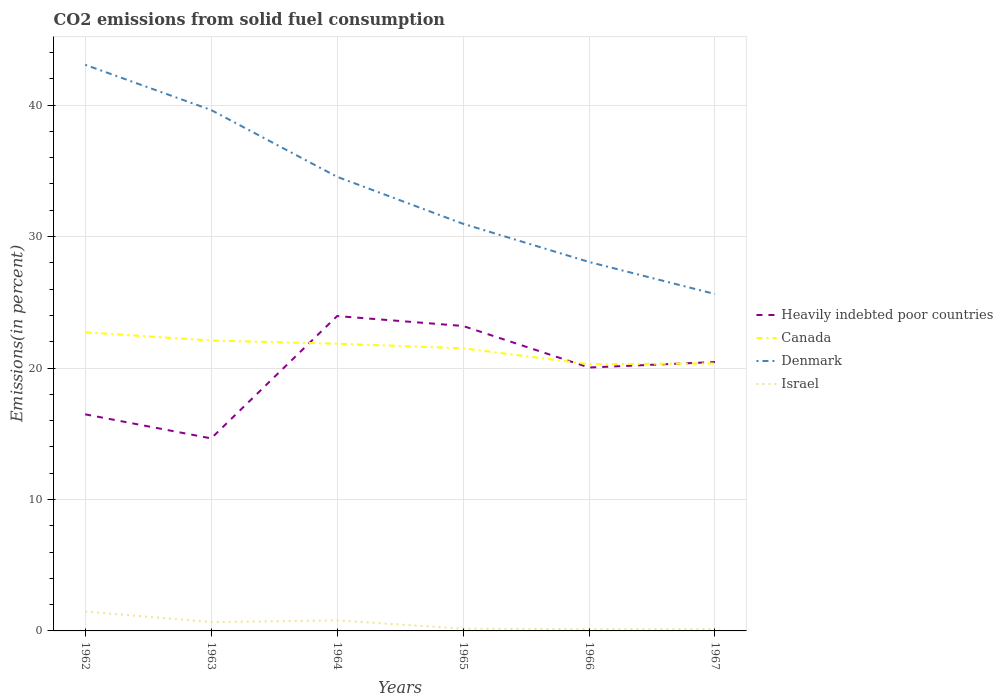How many different coloured lines are there?
Ensure brevity in your answer.  4. Does the line corresponding to Denmark intersect with the line corresponding to Canada?
Offer a very short reply. No. Across all years, what is the maximum total CO2 emitted in Israel?
Give a very brief answer. 0.13. In which year was the total CO2 emitted in Denmark maximum?
Offer a very short reply. 1967. What is the total total CO2 emitted in Israel in the graph?
Your answer should be very brief. 0.53. What is the difference between the highest and the second highest total CO2 emitted in Heavily indebted poor countries?
Provide a short and direct response. 9.31. Is the total CO2 emitted in Canada strictly greater than the total CO2 emitted in Heavily indebted poor countries over the years?
Give a very brief answer. No. How many lines are there?
Keep it short and to the point. 4. How many years are there in the graph?
Give a very brief answer. 6. What is the difference between two consecutive major ticks on the Y-axis?
Offer a terse response. 10. Are the values on the major ticks of Y-axis written in scientific E-notation?
Provide a succinct answer. No. Does the graph contain any zero values?
Ensure brevity in your answer.  No. Does the graph contain grids?
Offer a terse response. Yes. Where does the legend appear in the graph?
Keep it short and to the point. Center right. How many legend labels are there?
Ensure brevity in your answer.  4. What is the title of the graph?
Provide a succinct answer. CO2 emissions from solid fuel consumption. What is the label or title of the X-axis?
Your answer should be compact. Years. What is the label or title of the Y-axis?
Your response must be concise. Emissions(in percent). What is the Emissions(in percent) in Heavily indebted poor countries in 1962?
Offer a terse response. 16.48. What is the Emissions(in percent) in Canada in 1962?
Provide a succinct answer. 22.72. What is the Emissions(in percent) in Denmark in 1962?
Give a very brief answer. 43.07. What is the Emissions(in percent) of Israel in 1962?
Your answer should be very brief. 1.48. What is the Emissions(in percent) of Heavily indebted poor countries in 1963?
Your answer should be compact. 14.65. What is the Emissions(in percent) of Canada in 1963?
Offer a terse response. 22.09. What is the Emissions(in percent) in Denmark in 1963?
Ensure brevity in your answer.  39.63. What is the Emissions(in percent) in Israel in 1963?
Your answer should be compact. 0.67. What is the Emissions(in percent) in Heavily indebted poor countries in 1964?
Your answer should be very brief. 23.95. What is the Emissions(in percent) in Canada in 1964?
Give a very brief answer. 21.85. What is the Emissions(in percent) of Denmark in 1964?
Provide a short and direct response. 34.55. What is the Emissions(in percent) in Israel in 1964?
Make the answer very short. 0.8. What is the Emissions(in percent) in Heavily indebted poor countries in 1965?
Keep it short and to the point. 23.2. What is the Emissions(in percent) in Canada in 1965?
Keep it short and to the point. 21.5. What is the Emissions(in percent) of Denmark in 1965?
Your answer should be compact. 30.97. What is the Emissions(in percent) in Israel in 1965?
Keep it short and to the point. 0.17. What is the Emissions(in percent) in Heavily indebted poor countries in 1966?
Give a very brief answer. 20.04. What is the Emissions(in percent) of Canada in 1966?
Offer a terse response. 20.29. What is the Emissions(in percent) in Denmark in 1966?
Give a very brief answer. 28.07. What is the Emissions(in percent) in Israel in 1966?
Offer a very short reply. 0.13. What is the Emissions(in percent) in Heavily indebted poor countries in 1967?
Give a very brief answer. 20.46. What is the Emissions(in percent) in Canada in 1967?
Ensure brevity in your answer.  20.35. What is the Emissions(in percent) of Denmark in 1967?
Your answer should be compact. 25.63. What is the Emissions(in percent) in Israel in 1967?
Ensure brevity in your answer.  0.14. Across all years, what is the maximum Emissions(in percent) in Heavily indebted poor countries?
Offer a terse response. 23.95. Across all years, what is the maximum Emissions(in percent) in Canada?
Offer a terse response. 22.72. Across all years, what is the maximum Emissions(in percent) of Denmark?
Ensure brevity in your answer.  43.07. Across all years, what is the maximum Emissions(in percent) of Israel?
Give a very brief answer. 1.48. Across all years, what is the minimum Emissions(in percent) of Heavily indebted poor countries?
Offer a very short reply. 14.65. Across all years, what is the minimum Emissions(in percent) of Canada?
Provide a succinct answer. 20.29. Across all years, what is the minimum Emissions(in percent) in Denmark?
Keep it short and to the point. 25.63. Across all years, what is the minimum Emissions(in percent) of Israel?
Give a very brief answer. 0.13. What is the total Emissions(in percent) in Heavily indebted poor countries in the graph?
Make the answer very short. 118.77. What is the total Emissions(in percent) in Canada in the graph?
Ensure brevity in your answer.  128.81. What is the total Emissions(in percent) of Denmark in the graph?
Provide a short and direct response. 201.91. What is the total Emissions(in percent) of Israel in the graph?
Keep it short and to the point. 3.39. What is the difference between the Emissions(in percent) in Heavily indebted poor countries in 1962 and that in 1963?
Your answer should be very brief. 1.83. What is the difference between the Emissions(in percent) of Canada in 1962 and that in 1963?
Offer a very short reply. 0.63. What is the difference between the Emissions(in percent) in Denmark in 1962 and that in 1963?
Offer a very short reply. 3.44. What is the difference between the Emissions(in percent) of Israel in 1962 and that in 1963?
Your response must be concise. 0.81. What is the difference between the Emissions(in percent) of Heavily indebted poor countries in 1962 and that in 1964?
Make the answer very short. -7.48. What is the difference between the Emissions(in percent) in Canada in 1962 and that in 1964?
Offer a very short reply. 0.87. What is the difference between the Emissions(in percent) of Denmark in 1962 and that in 1964?
Offer a terse response. 8.52. What is the difference between the Emissions(in percent) in Israel in 1962 and that in 1964?
Keep it short and to the point. 0.68. What is the difference between the Emissions(in percent) of Heavily indebted poor countries in 1962 and that in 1965?
Your answer should be compact. -6.72. What is the difference between the Emissions(in percent) of Canada in 1962 and that in 1965?
Offer a very short reply. 1.22. What is the difference between the Emissions(in percent) of Denmark in 1962 and that in 1965?
Provide a short and direct response. 12.1. What is the difference between the Emissions(in percent) in Israel in 1962 and that in 1965?
Offer a very short reply. 1.31. What is the difference between the Emissions(in percent) of Heavily indebted poor countries in 1962 and that in 1966?
Your response must be concise. -3.56. What is the difference between the Emissions(in percent) in Canada in 1962 and that in 1966?
Provide a succinct answer. 2.42. What is the difference between the Emissions(in percent) of Denmark in 1962 and that in 1966?
Your answer should be compact. 15. What is the difference between the Emissions(in percent) in Israel in 1962 and that in 1966?
Your response must be concise. 1.34. What is the difference between the Emissions(in percent) of Heavily indebted poor countries in 1962 and that in 1967?
Your response must be concise. -3.98. What is the difference between the Emissions(in percent) in Canada in 1962 and that in 1967?
Offer a very short reply. 2.37. What is the difference between the Emissions(in percent) in Denmark in 1962 and that in 1967?
Ensure brevity in your answer.  17.44. What is the difference between the Emissions(in percent) of Israel in 1962 and that in 1967?
Make the answer very short. 1.34. What is the difference between the Emissions(in percent) in Heavily indebted poor countries in 1963 and that in 1964?
Your response must be concise. -9.31. What is the difference between the Emissions(in percent) in Canada in 1963 and that in 1964?
Keep it short and to the point. 0.24. What is the difference between the Emissions(in percent) of Denmark in 1963 and that in 1964?
Your answer should be very brief. 5.08. What is the difference between the Emissions(in percent) of Israel in 1963 and that in 1964?
Give a very brief answer. -0.13. What is the difference between the Emissions(in percent) in Heavily indebted poor countries in 1963 and that in 1965?
Your answer should be compact. -8.55. What is the difference between the Emissions(in percent) of Canada in 1963 and that in 1965?
Your answer should be very brief. 0.59. What is the difference between the Emissions(in percent) of Denmark in 1963 and that in 1965?
Give a very brief answer. 8.65. What is the difference between the Emissions(in percent) of Israel in 1963 and that in 1965?
Offer a very short reply. 0.5. What is the difference between the Emissions(in percent) in Heavily indebted poor countries in 1963 and that in 1966?
Your response must be concise. -5.39. What is the difference between the Emissions(in percent) of Canada in 1963 and that in 1966?
Provide a short and direct response. 1.8. What is the difference between the Emissions(in percent) of Denmark in 1963 and that in 1966?
Ensure brevity in your answer.  11.56. What is the difference between the Emissions(in percent) in Israel in 1963 and that in 1966?
Your answer should be compact. 0.54. What is the difference between the Emissions(in percent) in Heavily indebted poor countries in 1963 and that in 1967?
Give a very brief answer. -5.81. What is the difference between the Emissions(in percent) in Canada in 1963 and that in 1967?
Your answer should be very brief. 1.74. What is the difference between the Emissions(in percent) of Denmark in 1963 and that in 1967?
Make the answer very short. 14. What is the difference between the Emissions(in percent) of Israel in 1963 and that in 1967?
Give a very brief answer. 0.53. What is the difference between the Emissions(in percent) in Heavily indebted poor countries in 1964 and that in 1965?
Provide a succinct answer. 0.76. What is the difference between the Emissions(in percent) of Canada in 1964 and that in 1965?
Your answer should be very brief. 0.35. What is the difference between the Emissions(in percent) in Denmark in 1964 and that in 1965?
Make the answer very short. 3.57. What is the difference between the Emissions(in percent) in Israel in 1964 and that in 1965?
Give a very brief answer. 0.63. What is the difference between the Emissions(in percent) in Heavily indebted poor countries in 1964 and that in 1966?
Make the answer very short. 3.92. What is the difference between the Emissions(in percent) in Canada in 1964 and that in 1966?
Offer a terse response. 1.56. What is the difference between the Emissions(in percent) of Denmark in 1964 and that in 1966?
Your answer should be very brief. 6.48. What is the difference between the Emissions(in percent) of Israel in 1964 and that in 1966?
Make the answer very short. 0.67. What is the difference between the Emissions(in percent) in Heavily indebted poor countries in 1964 and that in 1967?
Keep it short and to the point. 3.5. What is the difference between the Emissions(in percent) of Canada in 1964 and that in 1967?
Keep it short and to the point. 1.5. What is the difference between the Emissions(in percent) in Denmark in 1964 and that in 1967?
Provide a succinct answer. 8.92. What is the difference between the Emissions(in percent) in Israel in 1964 and that in 1967?
Give a very brief answer. 0.67. What is the difference between the Emissions(in percent) of Heavily indebted poor countries in 1965 and that in 1966?
Provide a succinct answer. 3.16. What is the difference between the Emissions(in percent) in Canada in 1965 and that in 1966?
Provide a succinct answer. 1.21. What is the difference between the Emissions(in percent) in Denmark in 1965 and that in 1966?
Your response must be concise. 2.9. What is the difference between the Emissions(in percent) of Israel in 1965 and that in 1966?
Your answer should be very brief. 0.04. What is the difference between the Emissions(in percent) of Heavily indebted poor countries in 1965 and that in 1967?
Offer a very short reply. 2.74. What is the difference between the Emissions(in percent) of Canada in 1965 and that in 1967?
Provide a short and direct response. 1.15. What is the difference between the Emissions(in percent) in Denmark in 1965 and that in 1967?
Ensure brevity in your answer.  5.34. What is the difference between the Emissions(in percent) of Israel in 1965 and that in 1967?
Offer a very short reply. 0.03. What is the difference between the Emissions(in percent) in Heavily indebted poor countries in 1966 and that in 1967?
Your response must be concise. -0.42. What is the difference between the Emissions(in percent) in Canada in 1966 and that in 1967?
Keep it short and to the point. -0.06. What is the difference between the Emissions(in percent) in Denmark in 1966 and that in 1967?
Provide a short and direct response. 2.44. What is the difference between the Emissions(in percent) in Israel in 1966 and that in 1967?
Your answer should be very brief. -0. What is the difference between the Emissions(in percent) in Heavily indebted poor countries in 1962 and the Emissions(in percent) in Canada in 1963?
Provide a short and direct response. -5.61. What is the difference between the Emissions(in percent) of Heavily indebted poor countries in 1962 and the Emissions(in percent) of Denmark in 1963?
Offer a very short reply. -23.15. What is the difference between the Emissions(in percent) in Heavily indebted poor countries in 1962 and the Emissions(in percent) in Israel in 1963?
Offer a very short reply. 15.81. What is the difference between the Emissions(in percent) in Canada in 1962 and the Emissions(in percent) in Denmark in 1963?
Keep it short and to the point. -16.91. What is the difference between the Emissions(in percent) of Canada in 1962 and the Emissions(in percent) of Israel in 1963?
Give a very brief answer. 22.05. What is the difference between the Emissions(in percent) in Denmark in 1962 and the Emissions(in percent) in Israel in 1963?
Give a very brief answer. 42.4. What is the difference between the Emissions(in percent) of Heavily indebted poor countries in 1962 and the Emissions(in percent) of Canada in 1964?
Offer a terse response. -5.37. What is the difference between the Emissions(in percent) of Heavily indebted poor countries in 1962 and the Emissions(in percent) of Denmark in 1964?
Your answer should be very brief. -18.07. What is the difference between the Emissions(in percent) in Heavily indebted poor countries in 1962 and the Emissions(in percent) in Israel in 1964?
Give a very brief answer. 15.68. What is the difference between the Emissions(in percent) of Canada in 1962 and the Emissions(in percent) of Denmark in 1964?
Give a very brief answer. -11.83. What is the difference between the Emissions(in percent) in Canada in 1962 and the Emissions(in percent) in Israel in 1964?
Offer a terse response. 21.92. What is the difference between the Emissions(in percent) of Denmark in 1962 and the Emissions(in percent) of Israel in 1964?
Offer a very short reply. 42.27. What is the difference between the Emissions(in percent) of Heavily indebted poor countries in 1962 and the Emissions(in percent) of Canada in 1965?
Keep it short and to the point. -5.03. What is the difference between the Emissions(in percent) of Heavily indebted poor countries in 1962 and the Emissions(in percent) of Denmark in 1965?
Your response must be concise. -14.5. What is the difference between the Emissions(in percent) in Heavily indebted poor countries in 1962 and the Emissions(in percent) in Israel in 1965?
Your response must be concise. 16.31. What is the difference between the Emissions(in percent) of Canada in 1962 and the Emissions(in percent) of Denmark in 1965?
Ensure brevity in your answer.  -8.25. What is the difference between the Emissions(in percent) in Canada in 1962 and the Emissions(in percent) in Israel in 1965?
Provide a short and direct response. 22.55. What is the difference between the Emissions(in percent) in Denmark in 1962 and the Emissions(in percent) in Israel in 1965?
Make the answer very short. 42.9. What is the difference between the Emissions(in percent) in Heavily indebted poor countries in 1962 and the Emissions(in percent) in Canada in 1966?
Your response must be concise. -3.82. What is the difference between the Emissions(in percent) of Heavily indebted poor countries in 1962 and the Emissions(in percent) of Denmark in 1966?
Provide a short and direct response. -11.59. What is the difference between the Emissions(in percent) in Heavily indebted poor countries in 1962 and the Emissions(in percent) in Israel in 1966?
Provide a succinct answer. 16.34. What is the difference between the Emissions(in percent) of Canada in 1962 and the Emissions(in percent) of Denmark in 1966?
Provide a succinct answer. -5.35. What is the difference between the Emissions(in percent) of Canada in 1962 and the Emissions(in percent) of Israel in 1966?
Keep it short and to the point. 22.58. What is the difference between the Emissions(in percent) of Denmark in 1962 and the Emissions(in percent) of Israel in 1966?
Provide a succinct answer. 42.93. What is the difference between the Emissions(in percent) in Heavily indebted poor countries in 1962 and the Emissions(in percent) in Canada in 1967?
Keep it short and to the point. -3.87. What is the difference between the Emissions(in percent) of Heavily indebted poor countries in 1962 and the Emissions(in percent) of Denmark in 1967?
Your response must be concise. -9.15. What is the difference between the Emissions(in percent) in Heavily indebted poor countries in 1962 and the Emissions(in percent) in Israel in 1967?
Provide a short and direct response. 16.34. What is the difference between the Emissions(in percent) of Canada in 1962 and the Emissions(in percent) of Denmark in 1967?
Keep it short and to the point. -2.91. What is the difference between the Emissions(in percent) in Canada in 1962 and the Emissions(in percent) in Israel in 1967?
Your answer should be very brief. 22.58. What is the difference between the Emissions(in percent) in Denmark in 1962 and the Emissions(in percent) in Israel in 1967?
Provide a succinct answer. 42.93. What is the difference between the Emissions(in percent) in Heavily indebted poor countries in 1963 and the Emissions(in percent) in Canada in 1964?
Your answer should be compact. -7.2. What is the difference between the Emissions(in percent) in Heavily indebted poor countries in 1963 and the Emissions(in percent) in Denmark in 1964?
Provide a short and direct response. -19.9. What is the difference between the Emissions(in percent) in Heavily indebted poor countries in 1963 and the Emissions(in percent) in Israel in 1964?
Provide a succinct answer. 13.85. What is the difference between the Emissions(in percent) in Canada in 1963 and the Emissions(in percent) in Denmark in 1964?
Offer a very short reply. -12.46. What is the difference between the Emissions(in percent) of Canada in 1963 and the Emissions(in percent) of Israel in 1964?
Keep it short and to the point. 21.29. What is the difference between the Emissions(in percent) in Denmark in 1963 and the Emissions(in percent) in Israel in 1964?
Your answer should be very brief. 38.83. What is the difference between the Emissions(in percent) in Heavily indebted poor countries in 1963 and the Emissions(in percent) in Canada in 1965?
Make the answer very short. -6.86. What is the difference between the Emissions(in percent) in Heavily indebted poor countries in 1963 and the Emissions(in percent) in Denmark in 1965?
Your answer should be very brief. -16.33. What is the difference between the Emissions(in percent) of Heavily indebted poor countries in 1963 and the Emissions(in percent) of Israel in 1965?
Give a very brief answer. 14.48. What is the difference between the Emissions(in percent) of Canada in 1963 and the Emissions(in percent) of Denmark in 1965?
Ensure brevity in your answer.  -8.88. What is the difference between the Emissions(in percent) of Canada in 1963 and the Emissions(in percent) of Israel in 1965?
Your answer should be very brief. 21.92. What is the difference between the Emissions(in percent) of Denmark in 1963 and the Emissions(in percent) of Israel in 1965?
Give a very brief answer. 39.46. What is the difference between the Emissions(in percent) in Heavily indebted poor countries in 1963 and the Emissions(in percent) in Canada in 1966?
Provide a succinct answer. -5.65. What is the difference between the Emissions(in percent) of Heavily indebted poor countries in 1963 and the Emissions(in percent) of Denmark in 1966?
Provide a short and direct response. -13.42. What is the difference between the Emissions(in percent) of Heavily indebted poor countries in 1963 and the Emissions(in percent) of Israel in 1966?
Offer a terse response. 14.51. What is the difference between the Emissions(in percent) in Canada in 1963 and the Emissions(in percent) in Denmark in 1966?
Make the answer very short. -5.98. What is the difference between the Emissions(in percent) of Canada in 1963 and the Emissions(in percent) of Israel in 1966?
Your response must be concise. 21.96. What is the difference between the Emissions(in percent) of Denmark in 1963 and the Emissions(in percent) of Israel in 1966?
Give a very brief answer. 39.49. What is the difference between the Emissions(in percent) in Heavily indebted poor countries in 1963 and the Emissions(in percent) in Canada in 1967?
Give a very brief answer. -5.7. What is the difference between the Emissions(in percent) in Heavily indebted poor countries in 1963 and the Emissions(in percent) in Denmark in 1967?
Provide a succinct answer. -10.98. What is the difference between the Emissions(in percent) in Heavily indebted poor countries in 1963 and the Emissions(in percent) in Israel in 1967?
Make the answer very short. 14.51. What is the difference between the Emissions(in percent) of Canada in 1963 and the Emissions(in percent) of Denmark in 1967?
Ensure brevity in your answer.  -3.54. What is the difference between the Emissions(in percent) of Canada in 1963 and the Emissions(in percent) of Israel in 1967?
Ensure brevity in your answer.  21.96. What is the difference between the Emissions(in percent) of Denmark in 1963 and the Emissions(in percent) of Israel in 1967?
Offer a terse response. 39.49. What is the difference between the Emissions(in percent) in Heavily indebted poor countries in 1964 and the Emissions(in percent) in Canada in 1965?
Your answer should be very brief. 2.45. What is the difference between the Emissions(in percent) of Heavily indebted poor countries in 1964 and the Emissions(in percent) of Denmark in 1965?
Your answer should be compact. -7.02. What is the difference between the Emissions(in percent) of Heavily indebted poor countries in 1964 and the Emissions(in percent) of Israel in 1965?
Your answer should be very brief. 23.78. What is the difference between the Emissions(in percent) in Canada in 1964 and the Emissions(in percent) in Denmark in 1965?
Your answer should be compact. -9.12. What is the difference between the Emissions(in percent) of Canada in 1964 and the Emissions(in percent) of Israel in 1965?
Ensure brevity in your answer.  21.68. What is the difference between the Emissions(in percent) of Denmark in 1964 and the Emissions(in percent) of Israel in 1965?
Keep it short and to the point. 34.38. What is the difference between the Emissions(in percent) of Heavily indebted poor countries in 1964 and the Emissions(in percent) of Canada in 1966?
Your response must be concise. 3.66. What is the difference between the Emissions(in percent) of Heavily indebted poor countries in 1964 and the Emissions(in percent) of Denmark in 1966?
Ensure brevity in your answer.  -4.12. What is the difference between the Emissions(in percent) of Heavily indebted poor countries in 1964 and the Emissions(in percent) of Israel in 1966?
Make the answer very short. 23.82. What is the difference between the Emissions(in percent) in Canada in 1964 and the Emissions(in percent) in Denmark in 1966?
Provide a short and direct response. -6.22. What is the difference between the Emissions(in percent) of Canada in 1964 and the Emissions(in percent) of Israel in 1966?
Give a very brief answer. 21.72. What is the difference between the Emissions(in percent) in Denmark in 1964 and the Emissions(in percent) in Israel in 1966?
Provide a succinct answer. 34.41. What is the difference between the Emissions(in percent) of Heavily indebted poor countries in 1964 and the Emissions(in percent) of Canada in 1967?
Offer a very short reply. 3.6. What is the difference between the Emissions(in percent) of Heavily indebted poor countries in 1964 and the Emissions(in percent) of Denmark in 1967?
Give a very brief answer. -1.68. What is the difference between the Emissions(in percent) in Heavily indebted poor countries in 1964 and the Emissions(in percent) in Israel in 1967?
Ensure brevity in your answer.  23.82. What is the difference between the Emissions(in percent) in Canada in 1964 and the Emissions(in percent) in Denmark in 1967?
Your answer should be very brief. -3.78. What is the difference between the Emissions(in percent) of Canada in 1964 and the Emissions(in percent) of Israel in 1967?
Provide a succinct answer. 21.72. What is the difference between the Emissions(in percent) in Denmark in 1964 and the Emissions(in percent) in Israel in 1967?
Make the answer very short. 34.41. What is the difference between the Emissions(in percent) of Heavily indebted poor countries in 1965 and the Emissions(in percent) of Canada in 1966?
Give a very brief answer. 2.9. What is the difference between the Emissions(in percent) of Heavily indebted poor countries in 1965 and the Emissions(in percent) of Denmark in 1966?
Your answer should be very brief. -4.87. What is the difference between the Emissions(in percent) in Heavily indebted poor countries in 1965 and the Emissions(in percent) in Israel in 1966?
Offer a terse response. 23.06. What is the difference between the Emissions(in percent) of Canada in 1965 and the Emissions(in percent) of Denmark in 1966?
Your answer should be compact. -6.57. What is the difference between the Emissions(in percent) in Canada in 1965 and the Emissions(in percent) in Israel in 1966?
Your response must be concise. 21.37. What is the difference between the Emissions(in percent) in Denmark in 1965 and the Emissions(in percent) in Israel in 1966?
Your response must be concise. 30.84. What is the difference between the Emissions(in percent) in Heavily indebted poor countries in 1965 and the Emissions(in percent) in Canada in 1967?
Offer a terse response. 2.85. What is the difference between the Emissions(in percent) in Heavily indebted poor countries in 1965 and the Emissions(in percent) in Denmark in 1967?
Keep it short and to the point. -2.43. What is the difference between the Emissions(in percent) in Heavily indebted poor countries in 1965 and the Emissions(in percent) in Israel in 1967?
Offer a terse response. 23.06. What is the difference between the Emissions(in percent) in Canada in 1965 and the Emissions(in percent) in Denmark in 1967?
Your answer should be compact. -4.13. What is the difference between the Emissions(in percent) of Canada in 1965 and the Emissions(in percent) of Israel in 1967?
Give a very brief answer. 21.37. What is the difference between the Emissions(in percent) in Denmark in 1965 and the Emissions(in percent) in Israel in 1967?
Make the answer very short. 30.84. What is the difference between the Emissions(in percent) in Heavily indebted poor countries in 1966 and the Emissions(in percent) in Canada in 1967?
Provide a short and direct response. -0.31. What is the difference between the Emissions(in percent) in Heavily indebted poor countries in 1966 and the Emissions(in percent) in Denmark in 1967?
Make the answer very short. -5.59. What is the difference between the Emissions(in percent) in Heavily indebted poor countries in 1966 and the Emissions(in percent) in Israel in 1967?
Give a very brief answer. 19.9. What is the difference between the Emissions(in percent) in Canada in 1966 and the Emissions(in percent) in Denmark in 1967?
Your response must be concise. -5.34. What is the difference between the Emissions(in percent) in Canada in 1966 and the Emissions(in percent) in Israel in 1967?
Your answer should be very brief. 20.16. What is the difference between the Emissions(in percent) of Denmark in 1966 and the Emissions(in percent) of Israel in 1967?
Your response must be concise. 27.93. What is the average Emissions(in percent) in Heavily indebted poor countries per year?
Offer a very short reply. 19.79. What is the average Emissions(in percent) of Canada per year?
Offer a very short reply. 21.47. What is the average Emissions(in percent) of Denmark per year?
Provide a succinct answer. 33.65. What is the average Emissions(in percent) in Israel per year?
Offer a terse response. 0.56. In the year 1962, what is the difference between the Emissions(in percent) in Heavily indebted poor countries and Emissions(in percent) in Canada?
Your answer should be compact. -6.24. In the year 1962, what is the difference between the Emissions(in percent) of Heavily indebted poor countries and Emissions(in percent) of Denmark?
Keep it short and to the point. -26.59. In the year 1962, what is the difference between the Emissions(in percent) in Heavily indebted poor countries and Emissions(in percent) in Israel?
Ensure brevity in your answer.  15. In the year 1962, what is the difference between the Emissions(in percent) of Canada and Emissions(in percent) of Denmark?
Offer a very short reply. -20.35. In the year 1962, what is the difference between the Emissions(in percent) of Canada and Emissions(in percent) of Israel?
Your answer should be very brief. 21.24. In the year 1962, what is the difference between the Emissions(in percent) in Denmark and Emissions(in percent) in Israel?
Your answer should be very brief. 41.59. In the year 1963, what is the difference between the Emissions(in percent) in Heavily indebted poor countries and Emissions(in percent) in Canada?
Give a very brief answer. -7.44. In the year 1963, what is the difference between the Emissions(in percent) in Heavily indebted poor countries and Emissions(in percent) in Denmark?
Your answer should be compact. -24.98. In the year 1963, what is the difference between the Emissions(in percent) in Heavily indebted poor countries and Emissions(in percent) in Israel?
Make the answer very short. 13.98. In the year 1963, what is the difference between the Emissions(in percent) of Canada and Emissions(in percent) of Denmark?
Give a very brief answer. -17.54. In the year 1963, what is the difference between the Emissions(in percent) of Canada and Emissions(in percent) of Israel?
Keep it short and to the point. 21.42. In the year 1963, what is the difference between the Emissions(in percent) in Denmark and Emissions(in percent) in Israel?
Provide a short and direct response. 38.96. In the year 1964, what is the difference between the Emissions(in percent) in Heavily indebted poor countries and Emissions(in percent) in Canada?
Offer a terse response. 2.1. In the year 1964, what is the difference between the Emissions(in percent) in Heavily indebted poor countries and Emissions(in percent) in Denmark?
Offer a terse response. -10.59. In the year 1964, what is the difference between the Emissions(in percent) of Heavily indebted poor countries and Emissions(in percent) of Israel?
Your answer should be very brief. 23.15. In the year 1964, what is the difference between the Emissions(in percent) of Canada and Emissions(in percent) of Denmark?
Make the answer very short. -12.7. In the year 1964, what is the difference between the Emissions(in percent) in Canada and Emissions(in percent) in Israel?
Make the answer very short. 21.05. In the year 1964, what is the difference between the Emissions(in percent) in Denmark and Emissions(in percent) in Israel?
Make the answer very short. 33.75. In the year 1965, what is the difference between the Emissions(in percent) in Heavily indebted poor countries and Emissions(in percent) in Canada?
Make the answer very short. 1.7. In the year 1965, what is the difference between the Emissions(in percent) of Heavily indebted poor countries and Emissions(in percent) of Denmark?
Offer a terse response. -7.78. In the year 1965, what is the difference between the Emissions(in percent) in Heavily indebted poor countries and Emissions(in percent) in Israel?
Make the answer very short. 23.03. In the year 1965, what is the difference between the Emissions(in percent) of Canada and Emissions(in percent) of Denmark?
Make the answer very short. -9.47. In the year 1965, what is the difference between the Emissions(in percent) of Canada and Emissions(in percent) of Israel?
Keep it short and to the point. 21.33. In the year 1965, what is the difference between the Emissions(in percent) of Denmark and Emissions(in percent) of Israel?
Offer a terse response. 30.8. In the year 1966, what is the difference between the Emissions(in percent) in Heavily indebted poor countries and Emissions(in percent) in Canada?
Provide a short and direct response. -0.26. In the year 1966, what is the difference between the Emissions(in percent) of Heavily indebted poor countries and Emissions(in percent) of Denmark?
Your answer should be very brief. -8.03. In the year 1966, what is the difference between the Emissions(in percent) of Heavily indebted poor countries and Emissions(in percent) of Israel?
Ensure brevity in your answer.  19.9. In the year 1966, what is the difference between the Emissions(in percent) in Canada and Emissions(in percent) in Denmark?
Your answer should be compact. -7.78. In the year 1966, what is the difference between the Emissions(in percent) in Canada and Emissions(in percent) in Israel?
Your answer should be compact. 20.16. In the year 1966, what is the difference between the Emissions(in percent) of Denmark and Emissions(in percent) of Israel?
Your answer should be compact. 27.93. In the year 1967, what is the difference between the Emissions(in percent) of Heavily indebted poor countries and Emissions(in percent) of Canada?
Your answer should be compact. 0.11. In the year 1967, what is the difference between the Emissions(in percent) in Heavily indebted poor countries and Emissions(in percent) in Denmark?
Offer a very short reply. -5.17. In the year 1967, what is the difference between the Emissions(in percent) of Heavily indebted poor countries and Emissions(in percent) of Israel?
Make the answer very short. 20.32. In the year 1967, what is the difference between the Emissions(in percent) of Canada and Emissions(in percent) of Denmark?
Make the answer very short. -5.28. In the year 1967, what is the difference between the Emissions(in percent) of Canada and Emissions(in percent) of Israel?
Your answer should be very brief. 20.21. In the year 1967, what is the difference between the Emissions(in percent) in Denmark and Emissions(in percent) in Israel?
Your answer should be very brief. 25.49. What is the ratio of the Emissions(in percent) of Heavily indebted poor countries in 1962 to that in 1963?
Provide a succinct answer. 1.12. What is the ratio of the Emissions(in percent) in Canada in 1962 to that in 1963?
Offer a very short reply. 1.03. What is the ratio of the Emissions(in percent) in Denmark in 1962 to that in 1963?
Provide a short and direct response. 1.09. What is the ratio of the Emissions(in percent) of Israel in 1962 to that in 1963?
Keep it short and to the point. 2.21. What is the ratio of the Emissions(in percent) in Heavily indebted poor countries in 1962 to that in 1964?
Ensure brevity in your answer.  0.69. What is the ratio of the Emissions(in percent) of Canada in 1962 to that in 1964?
Your answer should be very brief. 1.04. What is the ratio of the Emissions(in percent) of Denmark in 1962 to that in 1964?
Your answer should be compact. 1.25. What is the ratio of the Emissions(in percent) in Israel in 1962 to that in 1964?
Provide a succinct answer. 1.84. What is the ratio of the Emissions(in percent) of Heavily indebted poor countries in 1962 to that in 1965?
Your response must be concise. 0.71. What is the ratio of the Emissions(in percent) in Canada in 1962 to that in 1965?
Offer a terse response. 1.06. What is the ratio of the Emissions(in percent) in Denmark in 1962 to that in 1965?
Your answer should be very brief. 1.39. What is the ratio of the Emissions(in percent) of Israel in 1962 to that in 1965?
Provide a short and direct response. 8.69. What is the ratio of the Emissions(in percent) in Heavily indebted poor countries in 1962 to that in 1966?
Make the answer very short. 0.82. What is the ratio of the Emissions(in percent) in Canada in 1962 to that in 1966?
Provide a short and direct response. 1.12. What is the ratio of the Emissions(in percent) in Denmark in 1962 to that in 1966?
Your answer should be compact. 1.53. What is the ratio of the Emissions(in percent) in Israel in 1962 to that in 1966?
Offer a terse response. 10.96. What is the ratio of the Emissions(in percent) of Heavily indebted poor countries in 1962 to that in 1967?
Offer a terse response. 0.81. What is the ratio of the Emissions(in percent) of Canada in 1962 to that in 1967?
Give a very brief answer. 1.12. What is the ratio of the Emissions(in percent) of Denmark in 1962 to that in 1967?
Offer a terse response. 1.68. What is the ratio of the Emissions(in percent) of Israel in 1962 to that in 1967?
Provide a short and direct response. 10.91. What is the ratio of the Emissions(in percent) of Heavily indebted poor countries in 1963 to that in 1964?
Make the answer very short. 0.61. What is the ratio of the Emissions(in percent) of Denmark in 1963 to that in 1964?
Provide a succinct answer. 1.15. What is the ratio of the Emissions(in percent) in Israel in 1963 to that in 1964?
Keep it short and to the point. 0.84. What is the ratio of the Emissions(in percent) in Heavily indebted poor countries in 1963 to that in 1965?
Your answer should be compact. 0.63. What is the ratio of the Emissions(in percent) in Canada in 1963 to that in 1965?
Your answer should be compact. 1.03. What is the ratio of the Emissions(in percent) in Denmark in 1963 to that in 1965?
Ensure brevity in your answer.  1.28. What is the ratio of the Emissions(in percent) of Israel in 1963 to that in 1965?
Provide a short and direct response. 3.94. What is the ratio of the Emissions(in percent) of Heavily indebted poor countries in 1963 to that in 1966?
Your answer should be compact. 0.73. What is the ratio of the Emissions(in percent) of Canada in 1963 to that in 1966?
Your response must be concise. 1.09. What is the ratio of the Emissions(in percent) in Denmark in 1963 to that in 1966?
Your answer should be very brief. 1.41. What is the ratio of the Emissions(in percent) in Israel in 1963 to that in 1966?
Your answer should be very brief. 4.97. What is the ratio of the Emissions(in percent) of Heavily indebted poor countries in 1963 to that in 1967?
Keep it short and to the point. 0.72. What is the ratio of the Emissions(in percent) of Canada in 1963 to that in 1967?
Offer a very short reply. 1.09. What is the ratio of the Emissions(in percent) of Denmark in 1963 to that in 1967?
Provide a succinct answer. 1.55. What is the ratio of the Emissions(in percent) in Israel in 1963 to that in 1967?
Offer a very short reply. 4.95. What is the ratio of the Emissions(in percent) of Heavily indebted poor countries in 1964 to that in 1965?
Ensure brevity in your answer.  1.03. What is the ratio of the Emissions(in percent) of Canada in 1964 to that in 1965?
Make the answer very short. 1.02. What is the ratio of the Emissions(in percent) of Denmark in 1964 to that in 1965?
Keep it short and to the point. 1.12. What is the ratio of the Emissions(in percent) in Israel in 1964 to that in 1965?
Make the answer very short. 4.72. What is the ratio of the Emissions(in percent) of Heavily indebted poor countries in 1964 to that in 1966?
Ensure brevity in your answer.  1.2. What is the ratio of the Emissions(in percent) of Canada in 1964 to that in 1966?
Give a very brief answer. 1.08. What is the ratio of the Emissions(in percent) in Denmark in 1964 to that in 1966?
Your response must be concise. 1.23. What is the ratio of the Emissions(in percent) of Israel in 1964 to that in 1966?
Provide a short and direct response. 5.94. What is the ratio of the Emissions(in percent) of Heavily indebted poor countries in 1964 to that in 1967?
Keep it short and to the point. 1.17. What is the ratio of the Emissions(in percent) in Canada in 1964 to that in 1967?
Offer a terse response. 1.07. What is the ratio of the Emissions(in percent) in Denmark in 1964 to that in 1967?
Your answer should be compact. 1.35. What is the ratio of the Emissions(in percent) of Israel in 1964 to that in 1967?
Offer a terse response. 5.92. What is the ratio of the Emissions(in percent) of Heavily indebted poor countries in 1965 to that in 1966?
Provide a short and direct response. 1.16. What is the ratio of the Emissions(in percent) of Canada in 1965 to that in 1966?
Give a very brief answer. 1.06. What is the ratio of the Emissions(in percent) of Denmark in 1965 to that in 1966?
Your answer should be very brief. 1.1. What is the ratio of the Emissions(in percent) in Israel in 1965 to that in 1966?
Give a very brief answer. 1.26. What is the ratio of the Emissions(in percent) of Heavily indebted poor countries in 1965 to that in 1967?
Keep it short and to the point. 1.13. What is the ratio of the Emissions(in percent) of Canada in 1965 to that in 1967?
Offer a terse response. 1.06. What is the ratio of the Emissions(in percent) in Denmark in 1965 to that in 1967?
Provide a short and direct response. 1.21. What is the ratio of the Emissions(in percent) in Israel in 1965 to that in 1967?
Provide a short and direct response. 1.26. What is the ratio of the Emissions(in percent) in Heavily indebted poor countries in 1966 to that in 1967?
Your answer should be compact. 0.98. What is the ratio of the Emissions(in percent) of Canada in 1966 to that in 1967?
Your response must be concise. 1. What is the ratio of the Emissions(in percent) in Denmark in 1966 to that in 1967?
Make the answer very short. 1.1. What is the difference between the highest and the second highest Emissions(in percent) in Heavily indebted poor countries?
Your answer should be compact. 0.76. What is the difference between the highest and the second highest Emissions(in percent) in Canada?
Provide a short and direct response. 0.63. What is the difference between the highest and the second highest Emissions(in percent) of Denmark?
Keep it short and to the point. 3.44. What is the difference between the highest and the second highest Emissions(in percent) in Israel?
Ensure brevity in your answer.  0.68. What is the difference between the highest and the lowest Emissions(in percent) of Heavily indebted poor countries?
Make the answer very short. 9.31. What is the difference between the highest and the lowest Emissions(in percent) of Canada?
Your answer should be compact. 2.42. What is the difference between the highest and the lowest Emissions(in percent) in Denmark?
Your answer should be very brief. 17.44. What is the difference between the highest and the lowest Emissions(in percent) in Israel?
Your response must be concise. 1.34. 